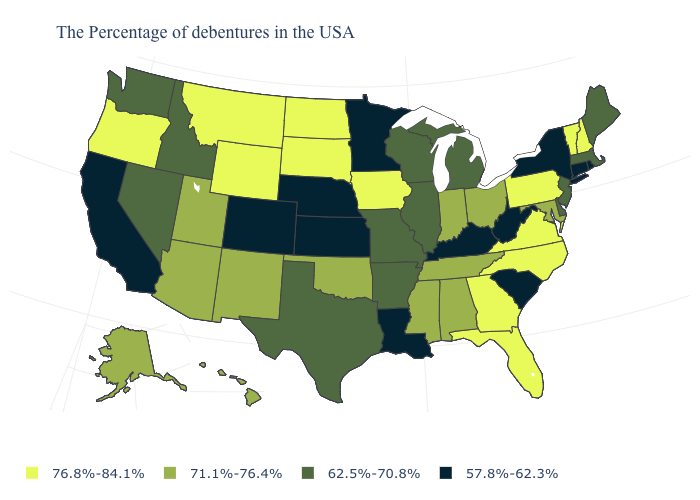Among the states that border South Dakota , does Nebraska have the lowest value?
Quick response, please. Yes. Is the legend a continuous bar?
Write a very short answer. No. Name the states that have a value in the range 62.5%-70.8%?
Keep it brief. Maine, Massachusetts, New Jersey, Delaware, Michigan, Wisconsin, Illinois, Missouri, Arkansas, Texas, Idaho, Nevada, Washington. How many symbols are there in the legend?
Write a very short answer. 4. What is the lowest value in the USA?
Be succinct. 57.8%-62.3%. What is the highest value in states that border Delaware?
Quick response, please. 76.8%-84.1%. Among the states that border New Mexico , which have the lowest value?
Short answer required. Colorado. Does Missouri have the lowest value in the MidWest?
Short answer required. No. Which states hav the highest value in the South?
Write a very short answer. Virginia, North Carolina, Florida, Georgia. What is the highest value in states that border Washington?
Keep it brief. 76.8%-84.1%. Does Delaware have the highest value in the USA?
Concise answer only. No. Is the legend a continuous bar?
Short answer required. No. Among the states that border Washington , which have the lowest value?
Write a very short answer. Idaho. What is the value of Michigan?
Give a very brief answer. 62.5%-70.8%. Name the states that have a value in the range 76.8%-84.1%?
Give a very brief answer. New Hampshire, Vermont, Pennsylvania, Virginia, North Carolina, Florida, Georgia, Iowa, South Dakota, North Dakota, Wyoming, Montana, Oregon. 